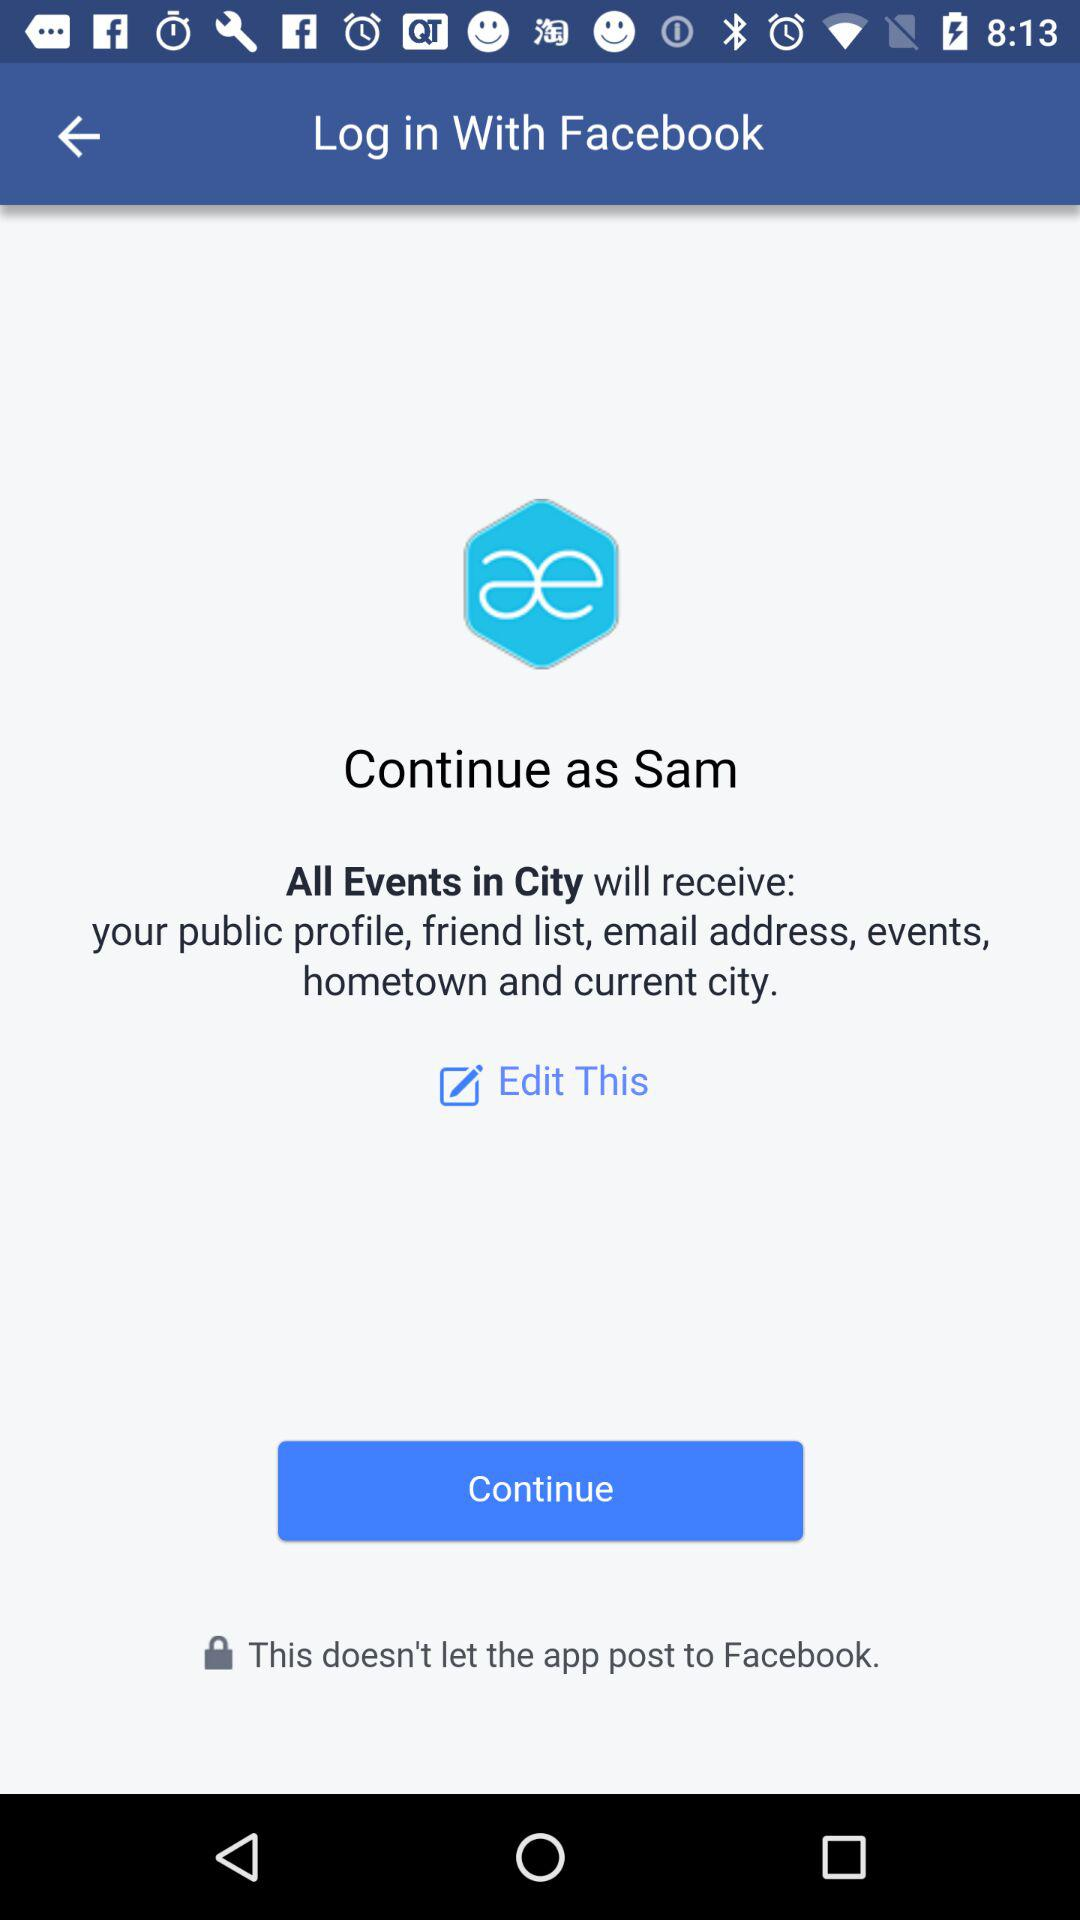What's the username? The username is "Sam". 